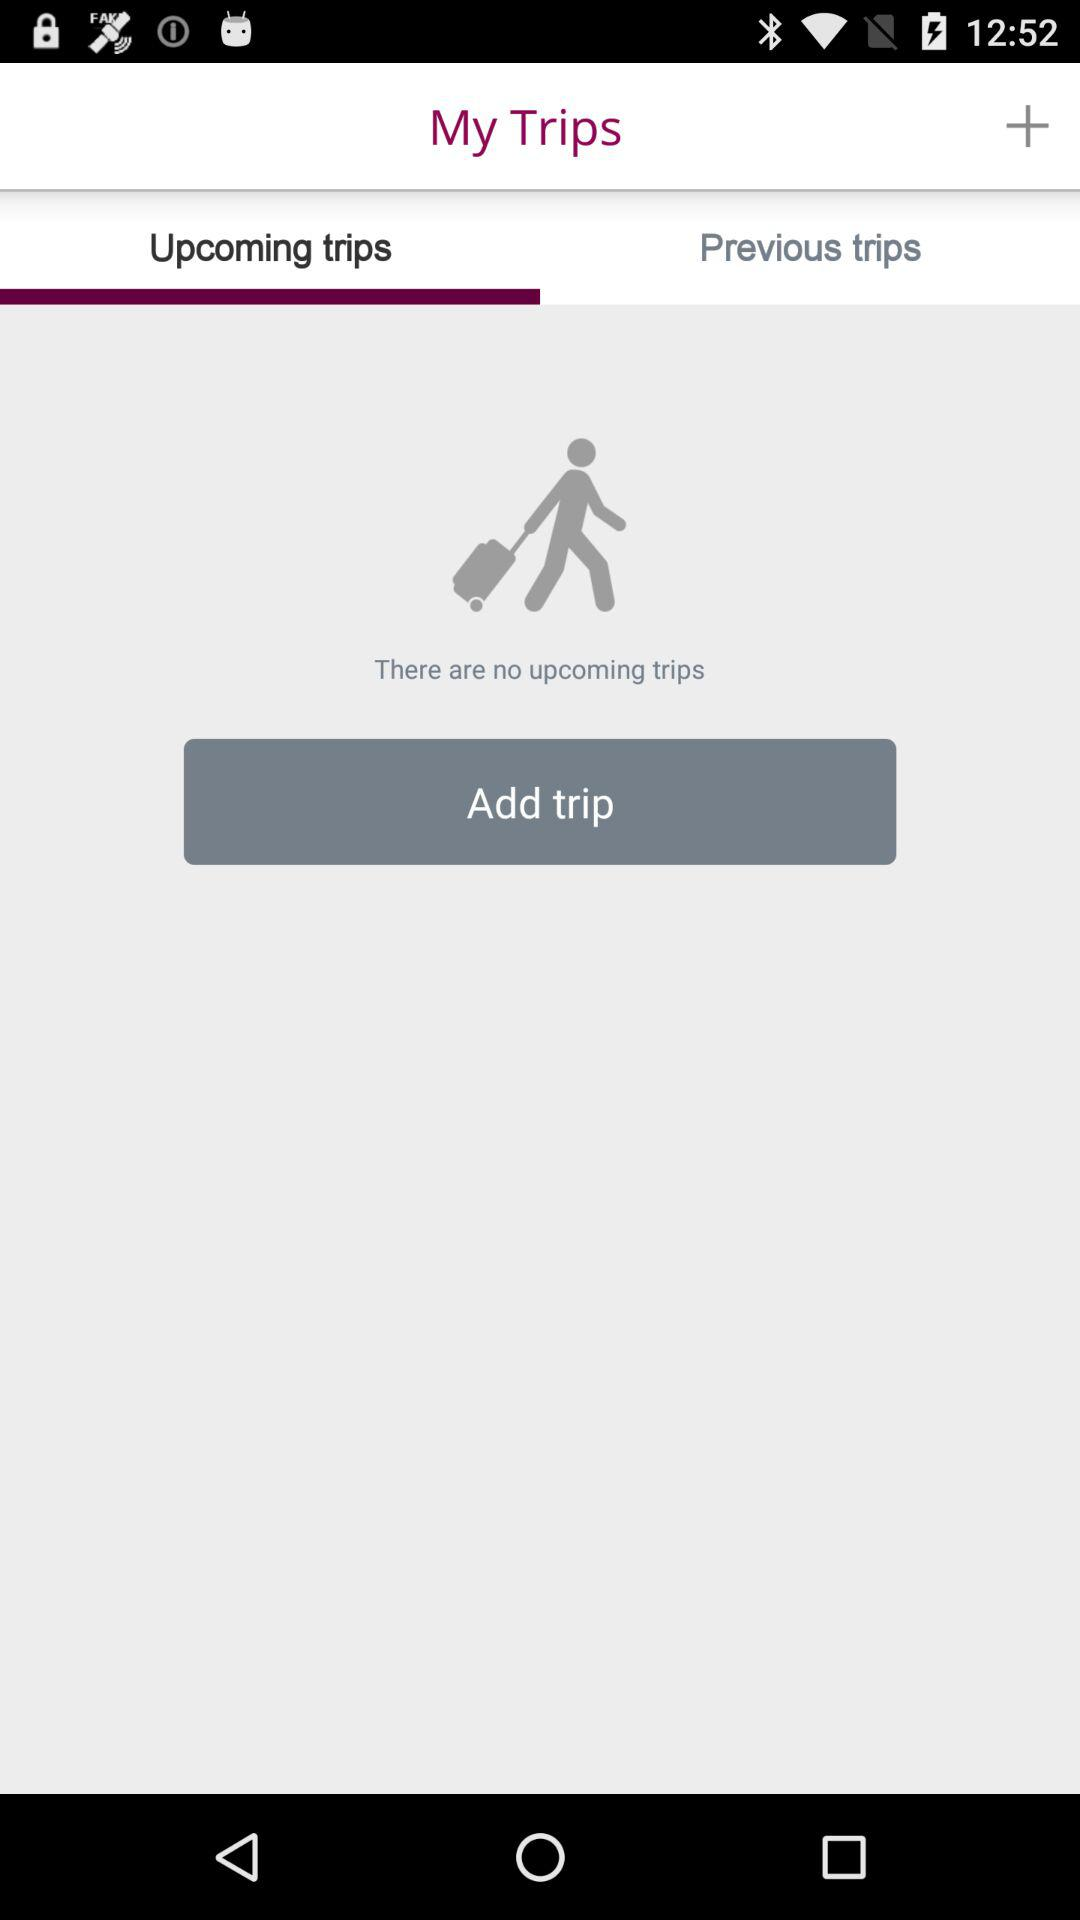Are there any upcoming trips? There are no upcoming trips. 